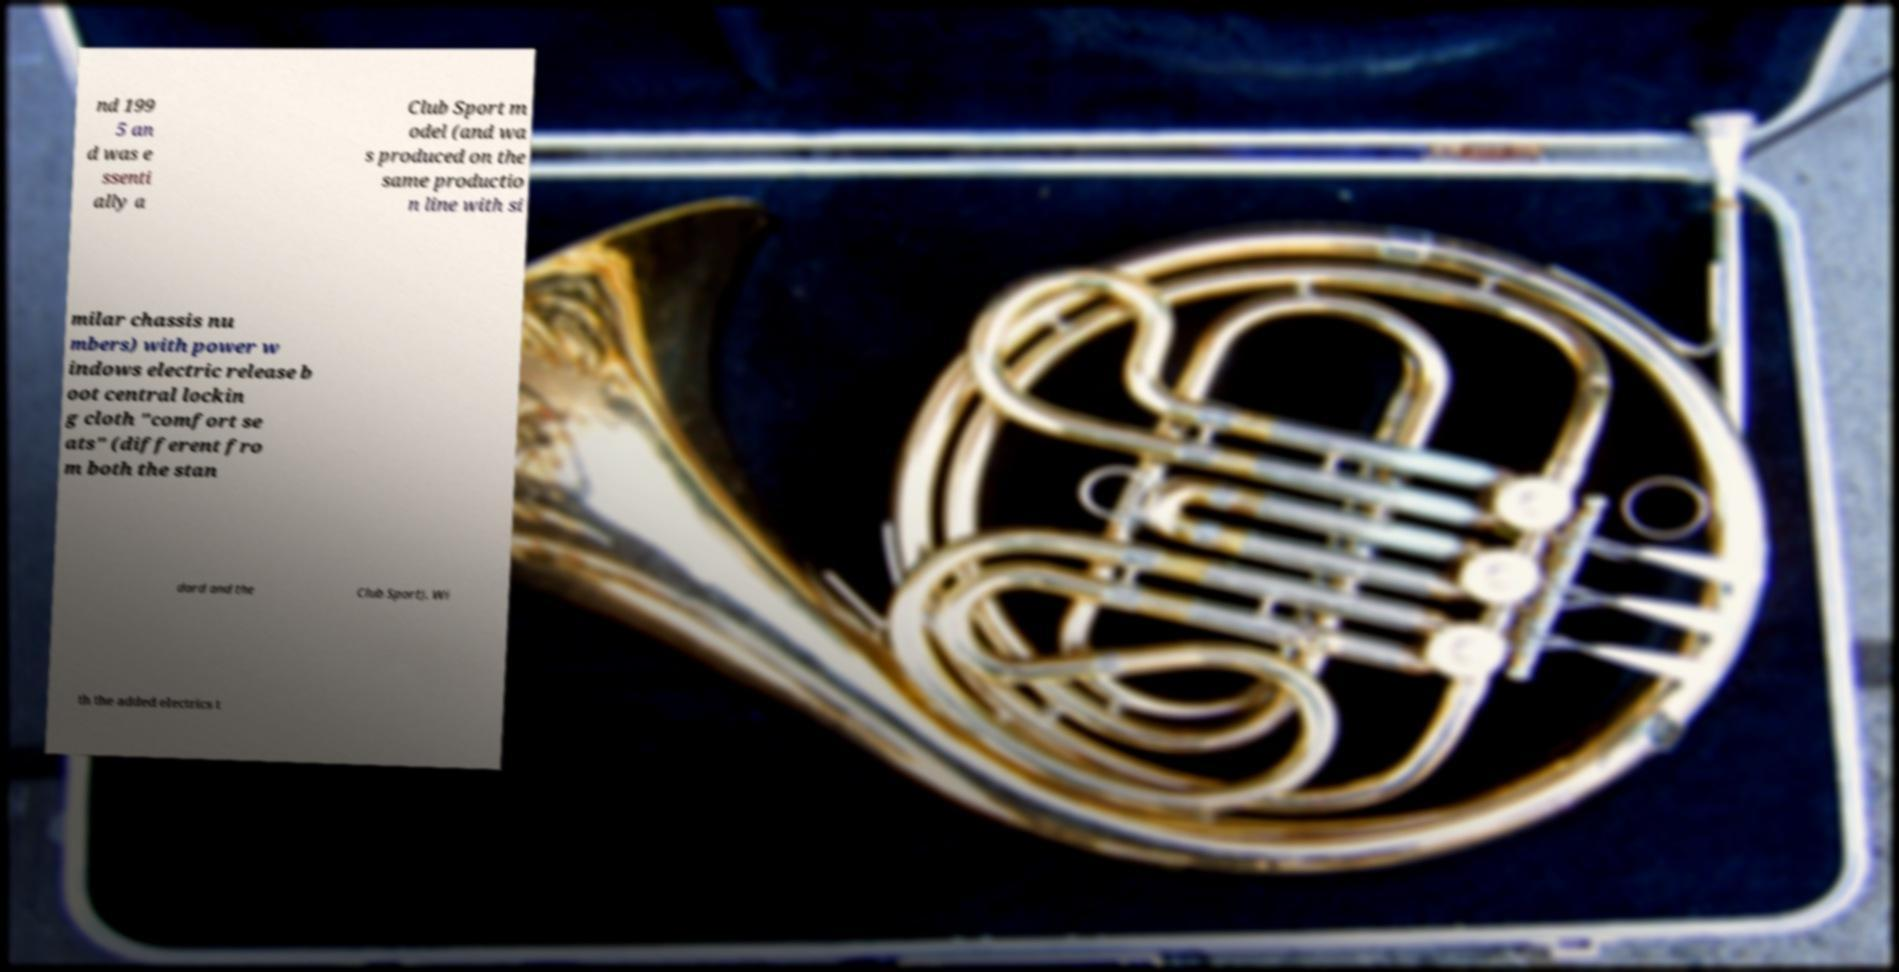Can you accurately transcribe the text from the provided image for me? nd 199 5 an d was e ssenti ally a Club Sport m odel (and wa s produced on the same productio n line with si milar chassis nu mbers) with power w indows electric release b oot central lockin g cloth "comfort se ats" (different fro m both the stan dard and the Club Sport). Wi th the added electrics t 